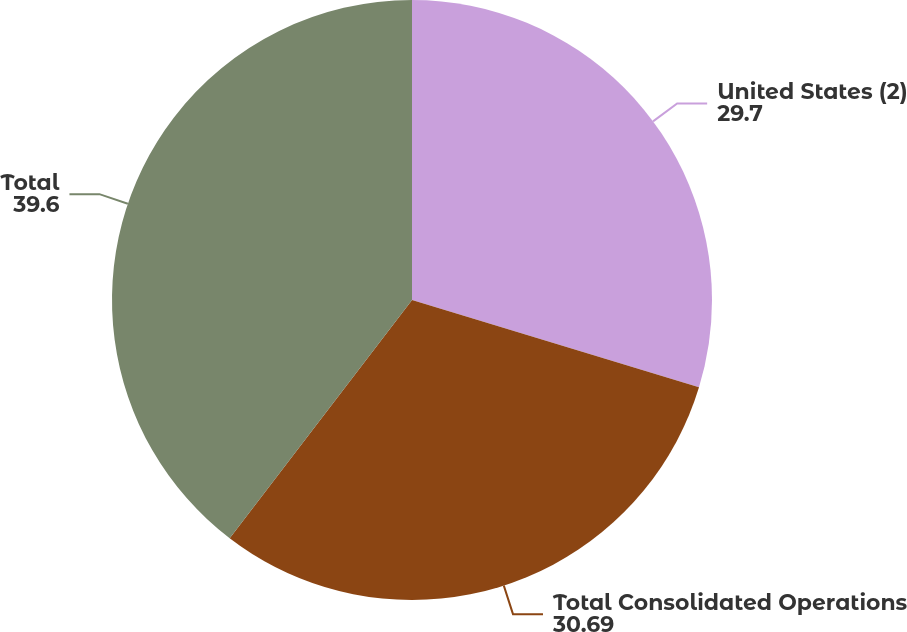Convert chart. <chart><loc_0><loc_0><loc_500><loc_500><pie_chart><fcel>United States (2)<fcel>Total Consolidated Operations<fcel>Total<nl><fcel>29.7%<fcel>30.69%<fcel>39.6%<nl></chart> 